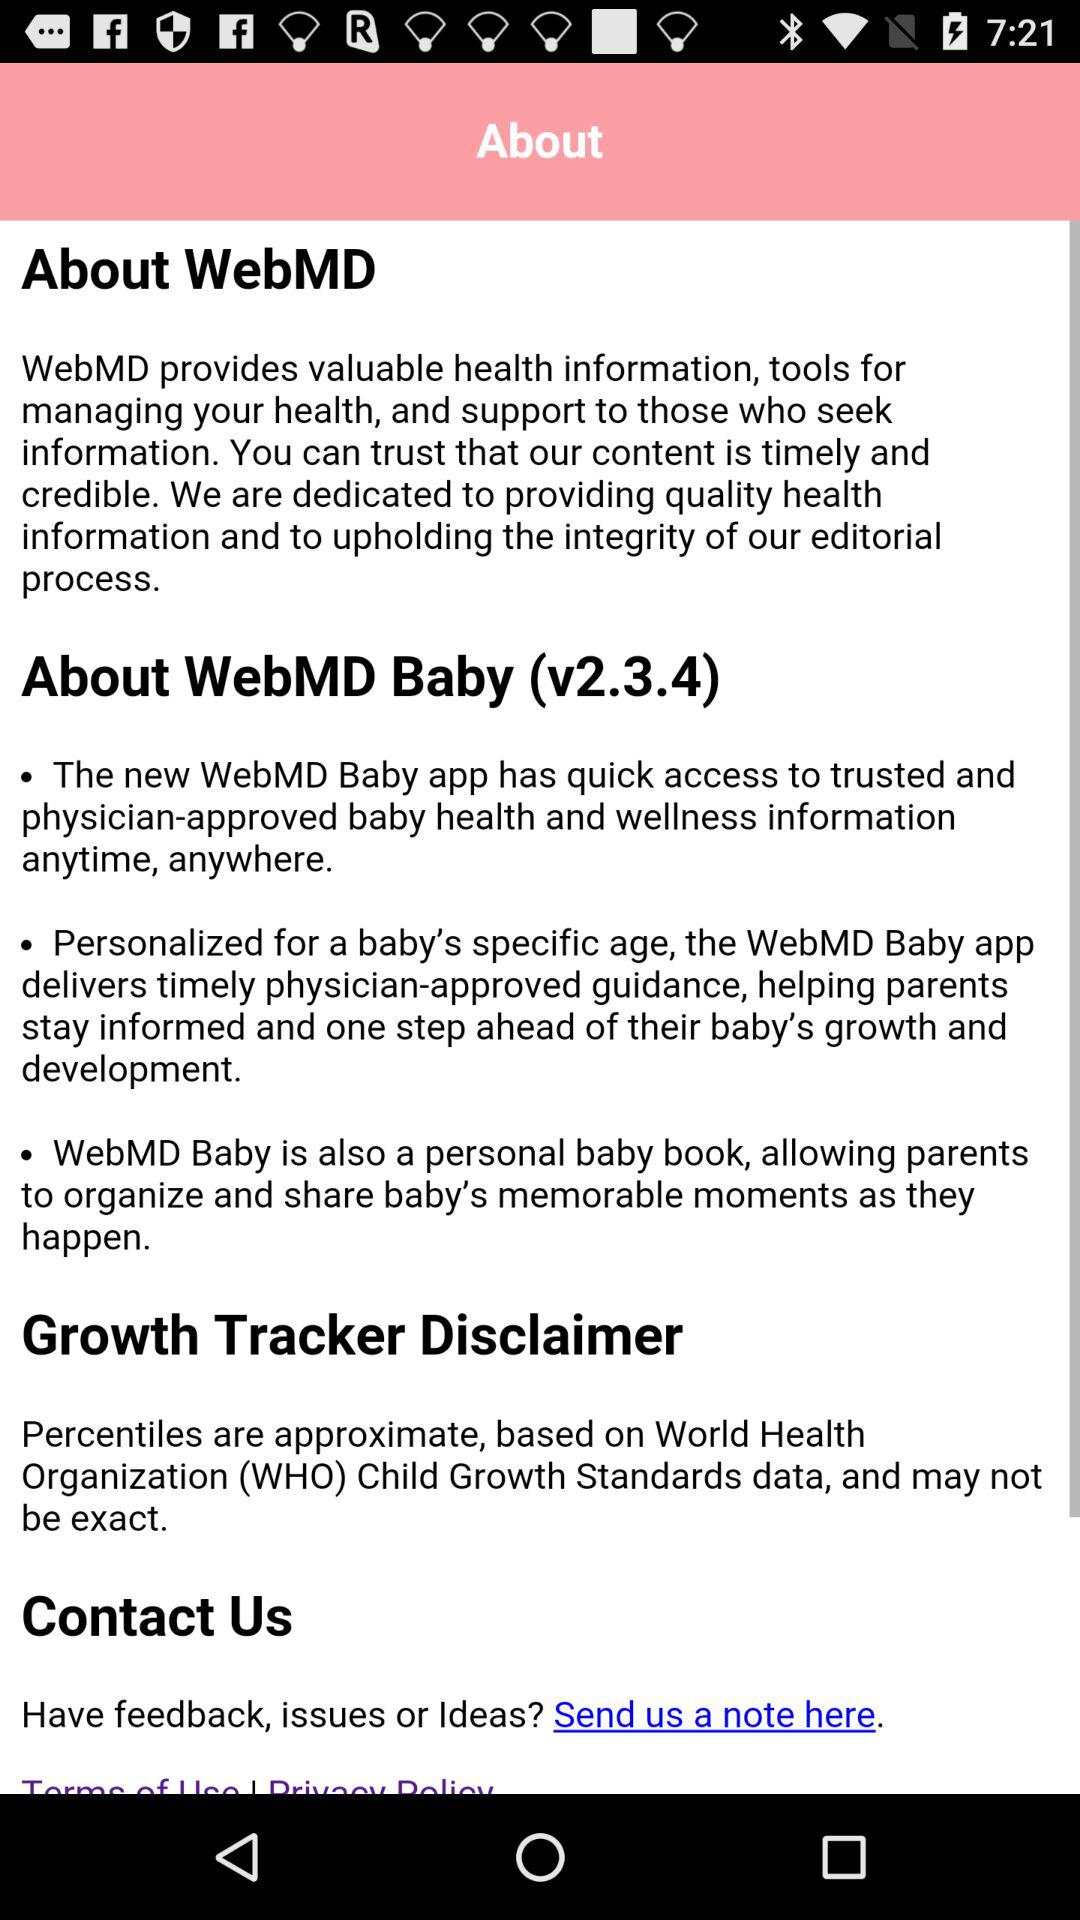What is the version of "WebMD"? The version is v2.3.4. 